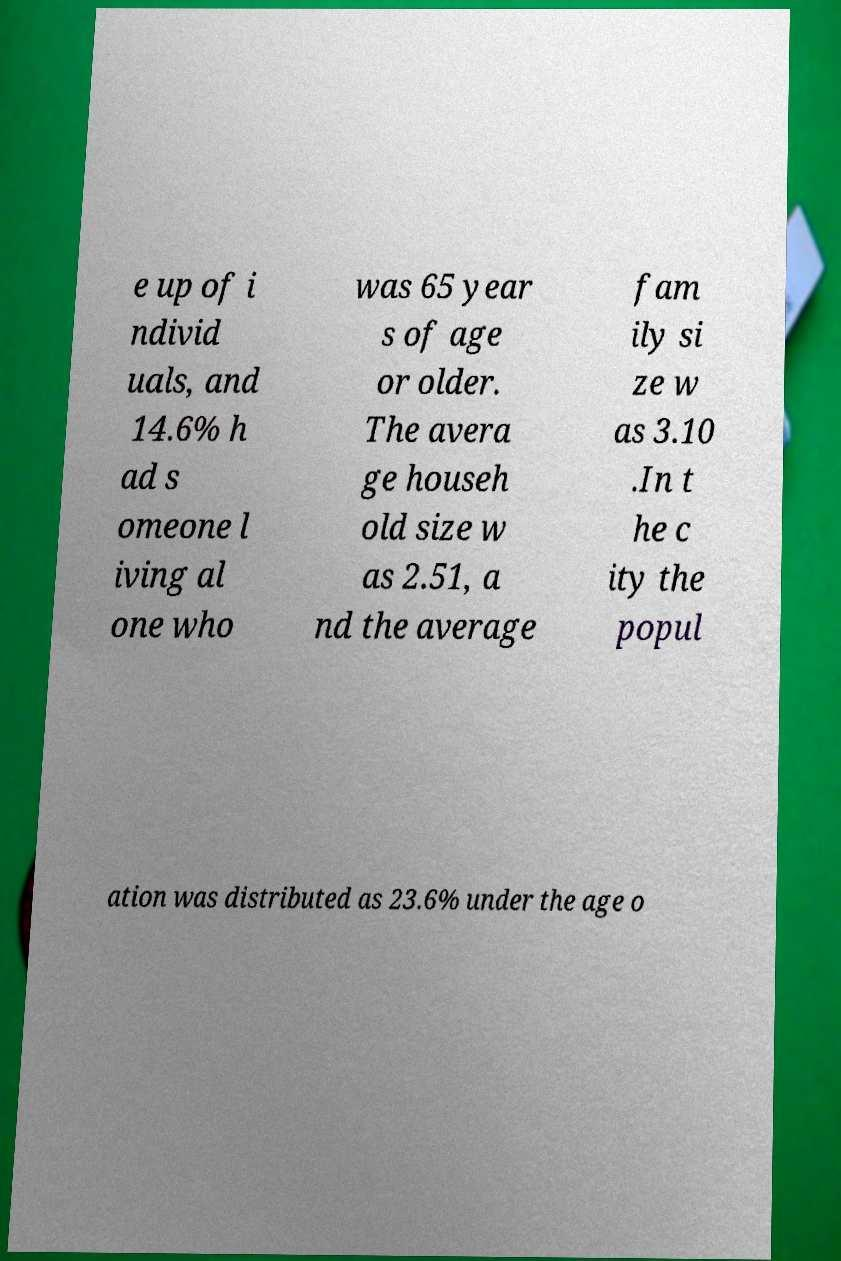Please read and relay the text visible in this image. What does it say? e up of i ndivid uals, and 14.6% h ad s omeone l iving al one who was 65 year s of age or older. The avera ge househ old size w as 2.51, a nd the average fam ily si ze w as 3.10 .In t he c ity the popul ation was distributed as 23.6% under the age o 